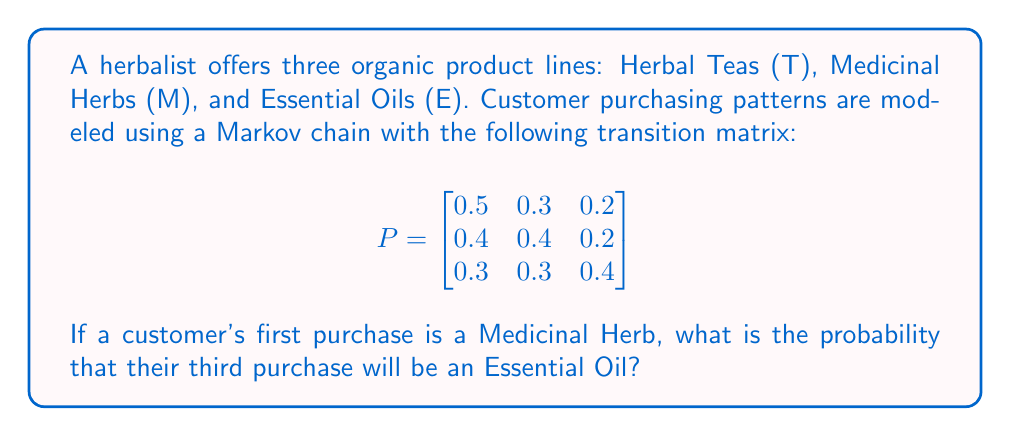Can you solve this math problem? To solve this problem, we need to use the Markov chain transition matrix to calculate the probability of reaching state E (Essential Oils) after two transitions, starting from state M (Medicinal Herbs).

Step 1: Identify the initial state vector.
Since the customer starts with Medicinal Herbs, the initial state vector is:
$$v_0 = \begin{bmatrix} 0 & 1 & 0 \end{bmatrix}$$

Step 2: Calculate the state after two transitions.
We need to multiply the initial state vector by the transition matrix twice:
$$v_2 = v_0 \cdot P^2$$

Step 3: Calculate $P^2$.
$$\begin{align}
P^2 &= P \cdot P \\
&= \begin{bmatrix}
0.5 & 0.3 & 0.2 \\
0.4 & 0.4 & 0.2 \\
0.3 & 0.3 & 0.4
\end{bmatrix} \cdot
\begin{bmatrix}
0.5 & 0.3 & 0.2 \\
0.4 & 0.4 & 0.2 \\
0.3 & 0.3 & 0.4
\end{bmatrix} \\
&= \begin{bmatrix}
0.46 & 0.33 & 0.21 \\
0.43 & 0.34 & 0.23 \\
0.39 & 0.33 & 0.28
\end{bmatrix}
\end{align}$$

Step 4: Multiply $v_0$ by $P^2$.
$$\begin{align}
v_2 &= v_0 \cdot P^2 \\
&= \begin{bmatrix} 0 & 1 & 0 \end{bmatrix} \cdot
\begin{bmatrix}
0.46 & 0.33 & 0.21 \\
0.43 & 0.34 & 0.23 \\
0.39 & 0.33 & 0.28
\end{bmatrix} \\
&= \begin{bmatrix} 0.43 & 0.34 & 0.23 \end{bmatrix}
\end{align}$$

Step 5: Identify the probability of being in state E (Essential Oils) after two transitions.
This is the third element of the resulting vector, which is 0.23.
Answer: 0.23 